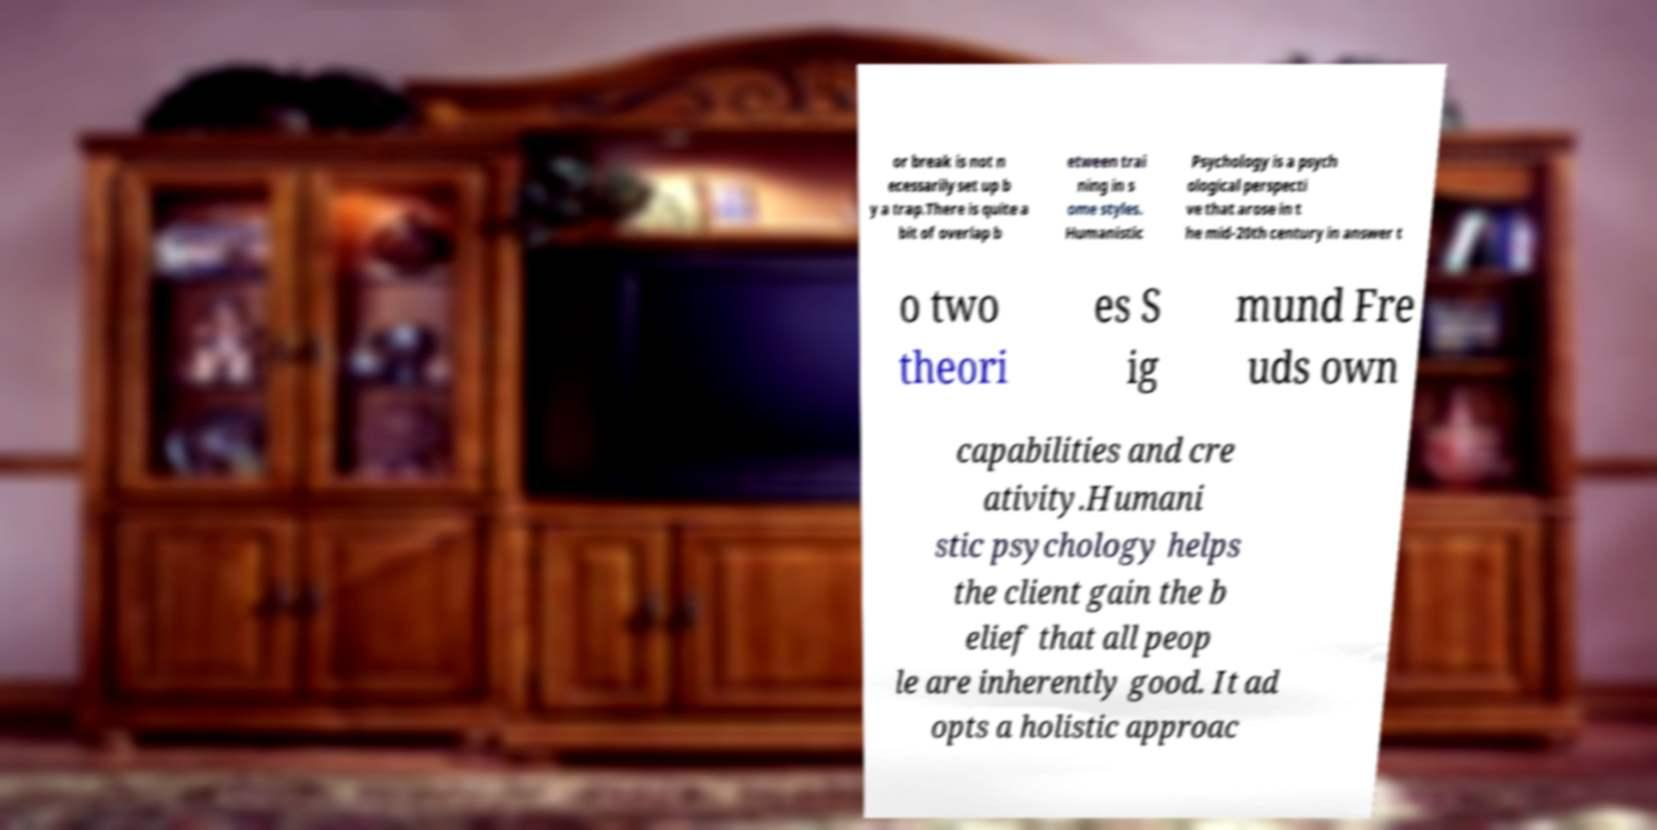For documentation purposes, I need the text within this image transcribed. Could you provide that? or break is not n ecessarily set up b y a trap.There is quite a bit of overlap b etween trai ning in s ome styles. Humanistic Psychology is a psych ological perspecti ve that arose in t he mid-20th century in answer t o two theori es S ig mund Fre uds own capabilities and cre ativity.Humani stic psychology helps the client gain the b elief that all peop le are inherently good. It ad opts a holistic approac 